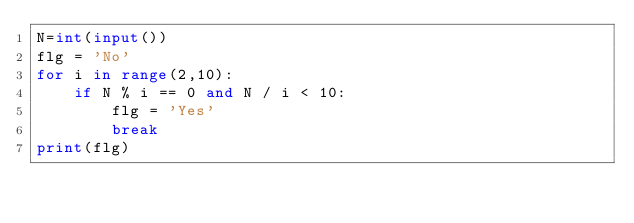<code> <loc_0><loc_0><loc_500><loc_500><_Python_>N=int(input())
flg = 'No'
for i in range(2,10):
    if N % i == 0 and N / i < 10:
        flg = 'Yes'
        break
print(flg)</code> 